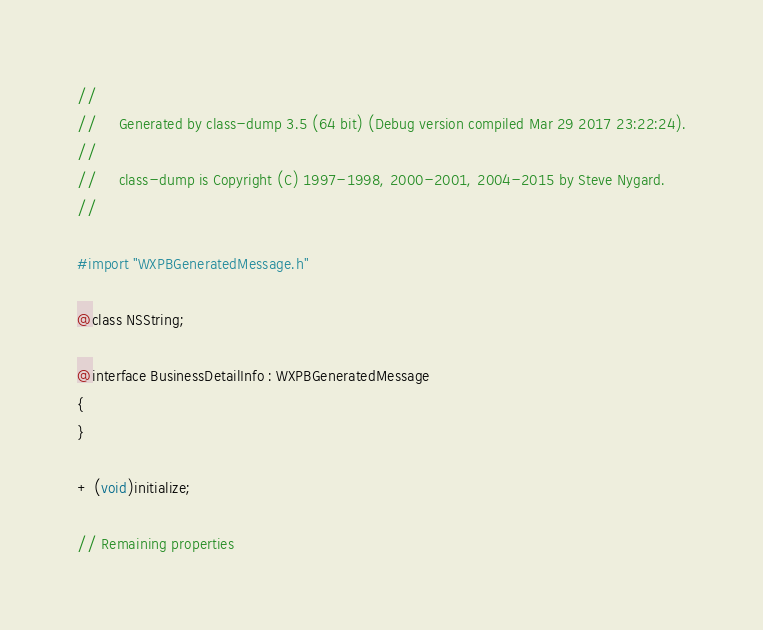Convert code to text. <code><loc_0><loc_0><loc_500><loc_500><_C_>//
//     Generated by class-dump 3.5 (64 bit) (Debug version compiled Mar 29 2017 23:22:24).
//
//     class-dump is Copyright (C) 1997-1998, 2000-2001, 2004-2015 by Steve Nygard.
//

#import "WXPBGeneratedMessage.h"

@class NSString;

@interface BusinessDetailInfo : WXPBGeneratedMessage
{
}

+ (void)initialize;

// Remaining properties</code> 